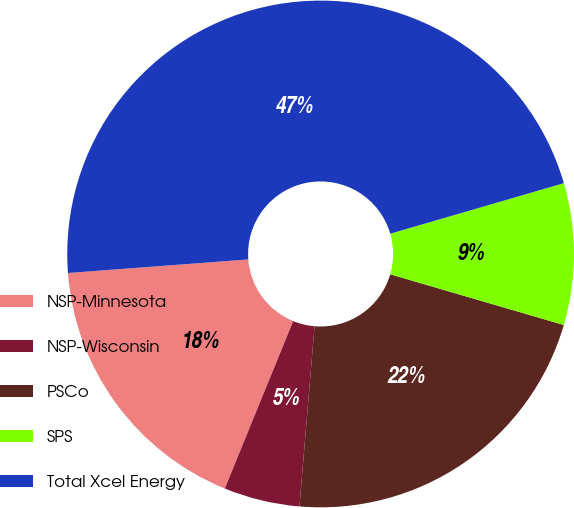<chart> <loc_0><loc_0><loc_500><loc_500><pie_chart><fcel>NSP-Minnesota<fcel>NSP-Wisconsin<fcel>PSCo<fcel>SPS<fcel>Total Xcel Energy<nl><fcel>17.63%<fcel>4.84%<fcel>21.81%<fcel>9.03%<fcel>46.69%<nl></chart> 